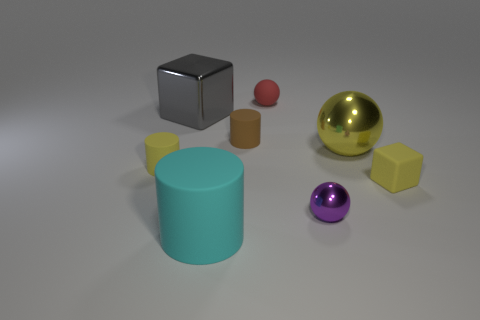The object that is both to the left of the brown cylinder and behind the yellow sphere has what shape?
Your answer should be compact. Cube. There is a cube that is the same material as the purple object; what is its size?
Make the answer very short. Large. Are there fewer large brown shiny blocks than gray metal cubes?
Your answer should be compact. Yes. What is the sphere on the left side of the metal sphere that is in front of the yellow matte thing on the right side of the gray thing made of?
Offer a very short reply. Rubber. Does the large object that is in front of the yellow shiny sphere have the same material as the tiny sphere that is in front of the yellow cube?
Make the answer very short. No. There is a metallic object that is both left of the large yellow thing and to the right of the gray metal object; how big is it?
Offer a terse response. Small. There is another ball that is the same size as the rubber ball; what is its material?
Provide a short and direct response. Metal. What number of brown cylinders are behind the cube on the left side of the tiny ball that is behind the gray metallic block?
Ensure brevity in your answer.  0. There is a large object that is on the right side of the cyan cylinder; is its color the same as the matte thing left of the large cyan rubber cylinder?
Provide a short and direct response. Yes. There is a large object that is to the left of the tiny purple shiny thing and behind the tiny yellow matte cylinder; what color is it?
Make the answer very short. Gray. 